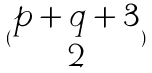<formula> <loc_0><loc_0><loc_500><loc_500>( \begin{matrix} p + q + 3 \\ 2 \end{matrix} )</formula> 